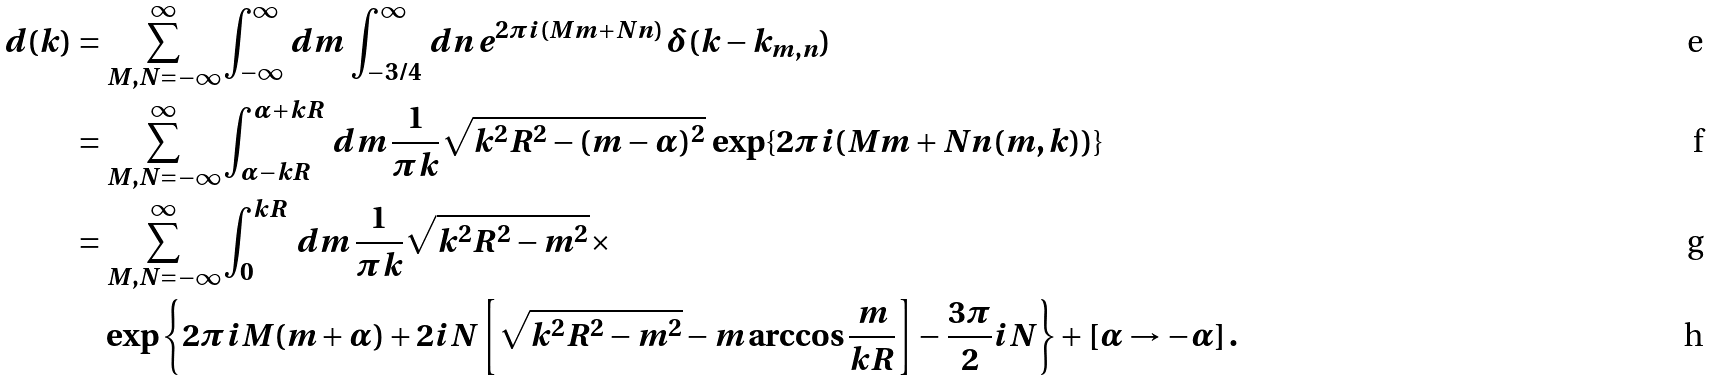Convert formula to latex. <formula><loc_0><loc_0><loc_500><loc_500>d ( k ) & = \sum _ { M , N = - \infty } ^ { \infty } \int _ { - \infty } ^ { \infty } \, d m \, \int _ { - 3 / 4 } ^ { \infty } \, d n \, e ^ { 2 \pi i ( M m + N n ) } \, \delta ( k - k _ { m , n } ) \\ & = \sum _ { M , N = - \infty } ^ { \infty } \int _ { \alpha - k R } ^ { \alpha + k R } \, d m \, \frac { 1 } { \pi k } \sqrt { k ^ { 2 } R ^ { 2 } - ( m - \alpha ) ^ { 2 } } \, \exp \{ 2 \pi i ( M m + N n ( m , k ) ) \} \\ & = \sum _ { M , N = - \infty } ^ { \infty } \int _ { 0 } ^ { k R } \, d m \, \frac { 1 } { \pi k } \sqrt { k ^ { 2 } R ^ { 2 } - m ^ { 2 } } \times \\ & \quad \exp \left \{ 2 \pi i M ( m + \alpha ) + 2 i N \left [ \sqrt { k ^ { 2 } R ^ { 2 } - m ^ { 2 } } - m \arccos \frac { m } { k R } \right ] - \frac { 3 \pi } { 2 } i N \right \} + [ \alpha \rightarrow - \alpha ] \, .</formula> 